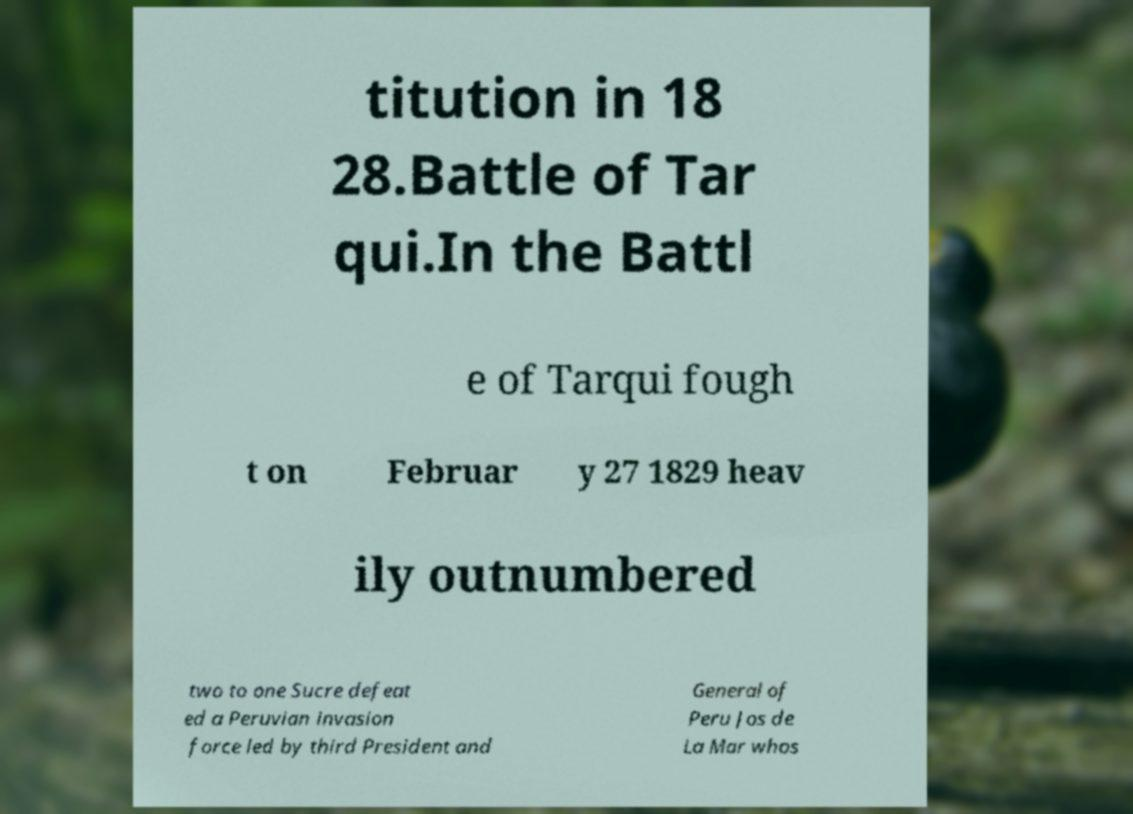Can you accurately transcribe the text from the provided image for me? titution in 18 28.Battle of Tar qui.In the Battl e of Tarqui fough t on Februar y 27 1829 heav ily outnumbered two to one Sucre defeat ed a Peruvian invasion force led by third President and General of Peru Jos de La Mar whos 